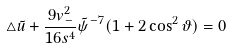<formula> <loc_0><loc_0><loc_500><loc_500>\triangle \tilde { u } + \frac { 9 v _ { - } ^ { 2 } } { 1 6 s ^ { 4 } } \tilde { \psi } ^ { - 7 } ( 1 + 2 \cos ^ { 2 } \vartheta ) = 0</formula> 